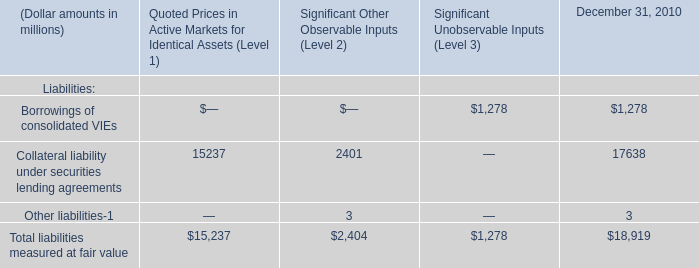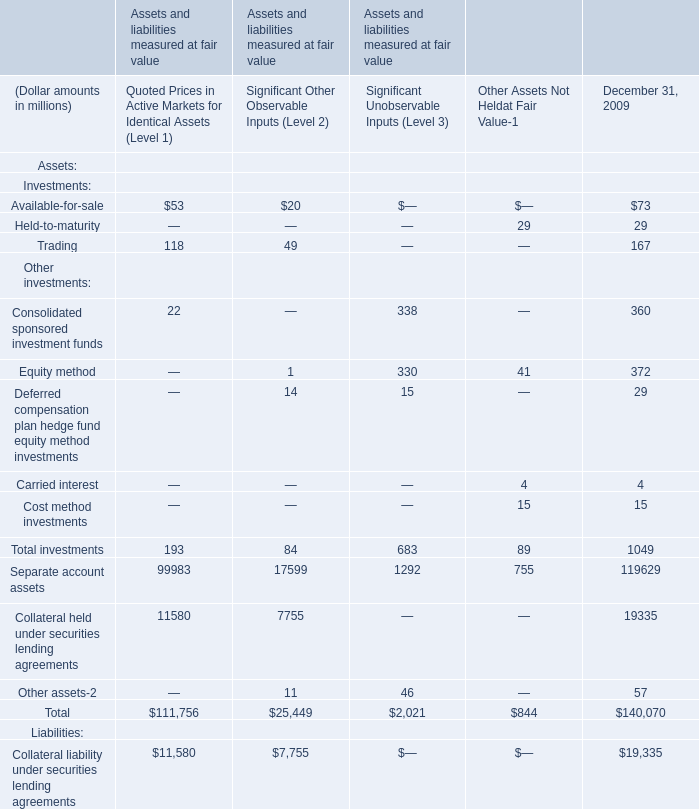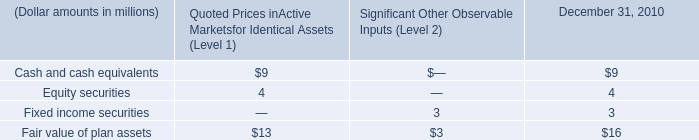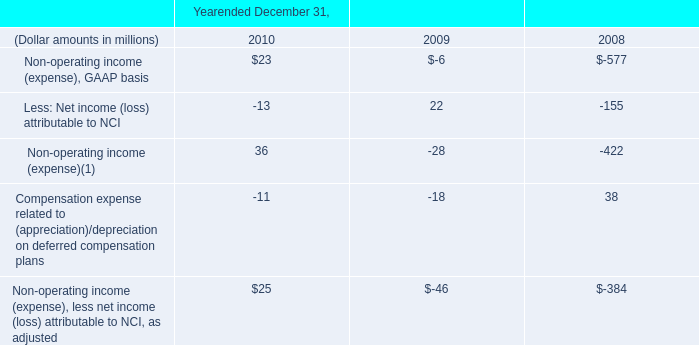What's the total amount of the Equity method in the years where Trading is greater than 0? (in million) 
Answer: 372. 